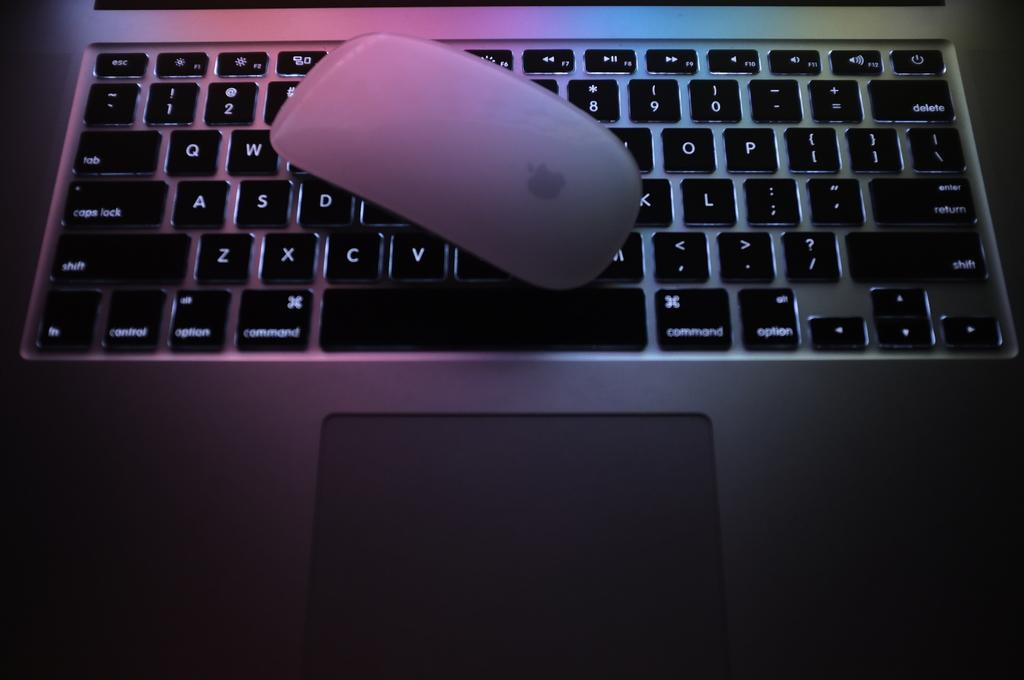<image>
Give a short and clear explanation of the subsequent image. An apple mouse is covering up part of the keyboard, but the command key is still visible. 